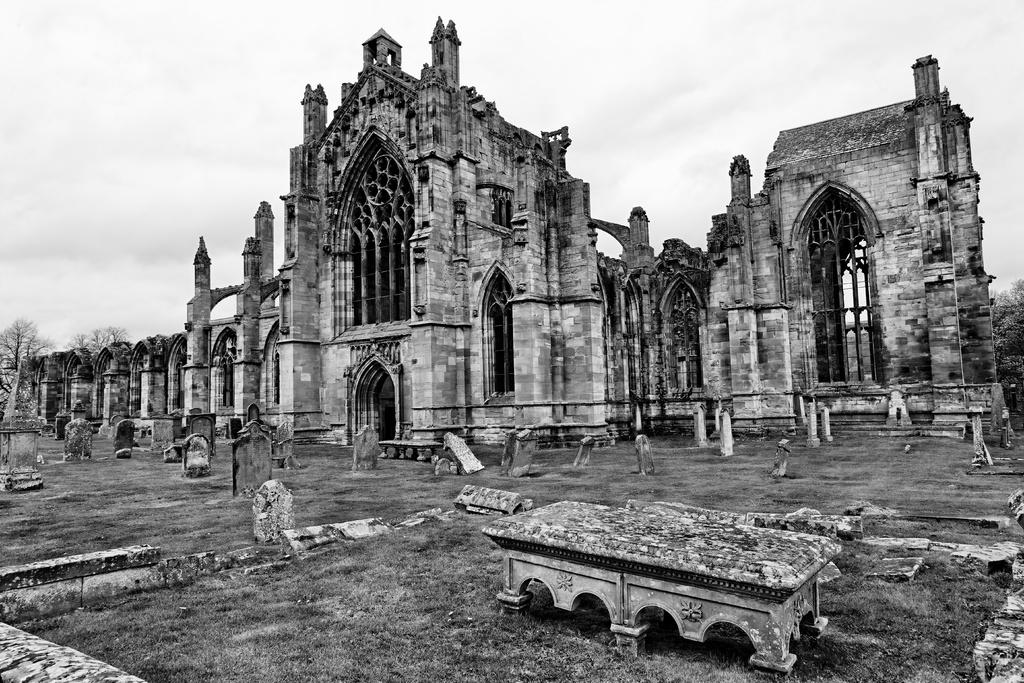What is the color scheme of the image? The image is black and white. What type of structure can be seen in the image? There is a building in the image. What can be found on the ground in the image? There are tombstones on the ground in the image. What is visible in the background of the image? The sky and trees are visible in the background of the image. What type of string instrument is being played in the image? There is no string instrument or any musical activity present in the image. What rhythm is being followed by the people in the image? There are no people or any indication of rhythm in the image. 